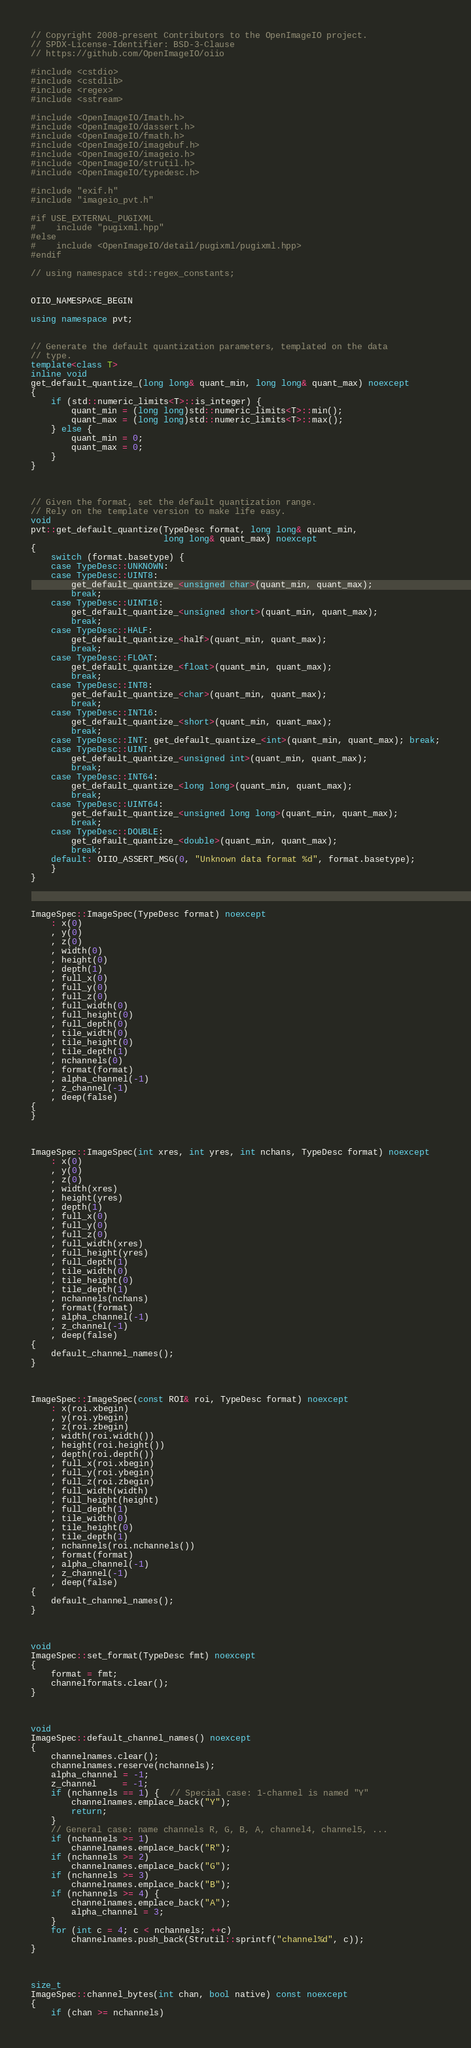Convert code to text. <code><loc_0><loc_0><loc_500><loc_500><_C++_>// Copyright 2008-present Contributors to the OpenImageIO project.
// SPDX-License-Identifier: BSD-3-Clause
// https://github.com/OpenImageIO/oiio

#include <cstdio>
#include <cstdlib>
#include <regex>
#include <sstream>

#include <OpenImageIO/Imath.h>
#include <OpenImageIO/dassert.h>
#include <OpenImageIO/fmath.h>
#include <OpenImageIO/imagebuf.h>
#include <OpenImageIO/imageio.h>
#include <OpenImageIO/strutil.h>
#include <OpenImageIO/typedesc.h>

#include "exif.h"
#include "imageio_pvt.h"

#if USE_EXTERNAL_PUGIXML
#    include "pugixml.hpp"
#else
#    include <OpenImageIO/detail/pugixml/pugixml.hpp>
#endif

// using namespace std::regex_constants;


OIIO_NAMESPACE_BEGIN

using namespace pvt;


// Generate the default quantization parameters, templated on the data
// type.
template<class T>
inline void
get_default_quantize_(long long& quant_min, long long& quant_max) noexcept
{
    if (std::numeric_limits<T>::is_integer) {
        quant_min = (long long)std::numeric_limits<T>::min();
        quant_max = (long long)std::numeric_limits<T>::max();
    } else {
        quant_min = 0;
        quant_max = 0;
    }
}



// Given the format, set the default quantization range.
// Rely on the template version to make life easy.
void
pvt::get_default_quantize(TypeDesc format, long long& quant_min,
                          long long& quant_max) noexcept
{
    switch (format.basetype) {
    case TypeDesc::UNKNOWN:
    case TypeDesc::UINT8:
        get_default_quantize_<unsigned char>(quant_min, quant_max);
        break;
    case TypeDesc::UINT16:
        get_default_quantize_<unsigned short>(quant_min, quant_max);
        break;
    case TypeDesc::HALF:
        get_default_quantize_<half>(quant_min, quant_max);
        break;
    case TypeDesc::FLOAT:
        get_default_quantize_<float>(quant_min, quant_max);
        break;
    case TypeDesc::INT8:
        get_default_quantize_<char>(quant_min, quant_max);
        break;
    case TypeDesc::INT16:
        get_default_quantize_<short>(quant_min, quant_max);
        break;
    case TypeDesc::INT: get_default_quantize_<int>(quant_min, quant_max); break;
    case TypeDesc::UINT:
        get_default_quantize_<unsigned int>(quant_min, quant_max);
        break;
    case TypeDesc::INT64:
        get_default_quantize_<long long>(quant_min, quant_max);
        break;
    case TypeDesc::UINT64:
        get_default_quantize_<unsigned long long>(quant_min, quant_max);
        break;
    case TypeDesc::DOUBLE:
        get_default_quantize_<double>(quant_min, quant_max);
        break;
    default: OIIO_ASSERT_MSG(0, "Unknown data format %d", format.basetype);
    }
}



ImageSpec::ImageSpec(TypeDesc format) noexcept
    : x(0)
    , y(0)
    , z(0)
    , width(0)
    , height(0)
    , depth(1)
    , full_x(0)
    , full_y(0)
    , full_z(0)
    , full_width(0)
    , full_height(0)
    , full_depth(0)
    , tile_width(0)
    , tile_height(0)
    , tile_depth(1)
    , nchannels(0)
    , format(format)
    , alpha_channel(-1)
    , z_channel(-1)
    , deep(false)
{
}



ImageSpec::ImageSpec(int xres, int yres, int nchans, TypeDesc format) noexcept
    : x(0)
    , y(0)
    , z(0)
    , width(xres)
    , height(yres)
    , depth(1)
    , full_x(0)
    , full_y(0)
    , full_z(0)
    , full_width(xres)
    , full_height(yres)
    , full_depth(1)
    , tile_width(0)
    , tile_height(0)
    , tile_depth(1)
    , nchannels(nchans)
    , format(format)
    , alpha_channel(-1)
    , z_channel(-1)
    , deep(false)
{
    default_channel_names();
}



ImageSpec::ImageSpec(const ROI& roi, TypeDesc format) noexcept
    : x(roi.xbegin)
    , y(roi.ybegin)
    , z(roi.zbegin)
    , width(roi.width())
    , height(roi.height())
    , depth(roi.depth())
    , full_x(roi.xbegin)
    , full_y(roi.ybegin)
    , full_z(roi.zbegin)
    , full_width(width)
    , full_height(height)
    , full_depth(1)
    , tile_width(0)
    , tile_height(0)
    , tile_depth(1)
    , nchannels(roi.nchannels())
    , format(format)
    , alpha_channel(-1)
    , z_channel(-1)
    , deep(false)
{
    default_channel_names();
}



void
ImageSpec::set_format(TypeDesc fmt) noexcept
{
    format = fmt;
    channelformats.clear();
}



void
ImageSpec::default_channel_names() noexcept
{
    channelnames.clear();
    channelnames.reserve(nchannels);
    alpha_channel = -1;
    z_channel     = -1;
    if (nchannels == 1) {  // Special case: 1-channel is named "Y"
        channelnames.emplace_back("Y");
        return;
    }
    // General case: name channels R, G, B, A, channel4, channel5, ...
    if (nchannels >= 1)
        channelnames.emplace_back("R");
    if (nchannels >= 2)
        channelnames.emplace_back("G");
    if (nchannels >= 3)
        channelnames.emplace_back("B");
    if (nchannels >= 4) {
        channelnames.emplace_back("A");
        alpha_channel = 3;
    }
    for (int c = 4; c < nchannels; ++c)
        channelnames.push_back(Strutil::sprintf("channel%d", c));
}



size_t
ImageSpec::channel_bytes(int chan, bool native) const noexcept
{
    if (chan >= nchannels)</code> 